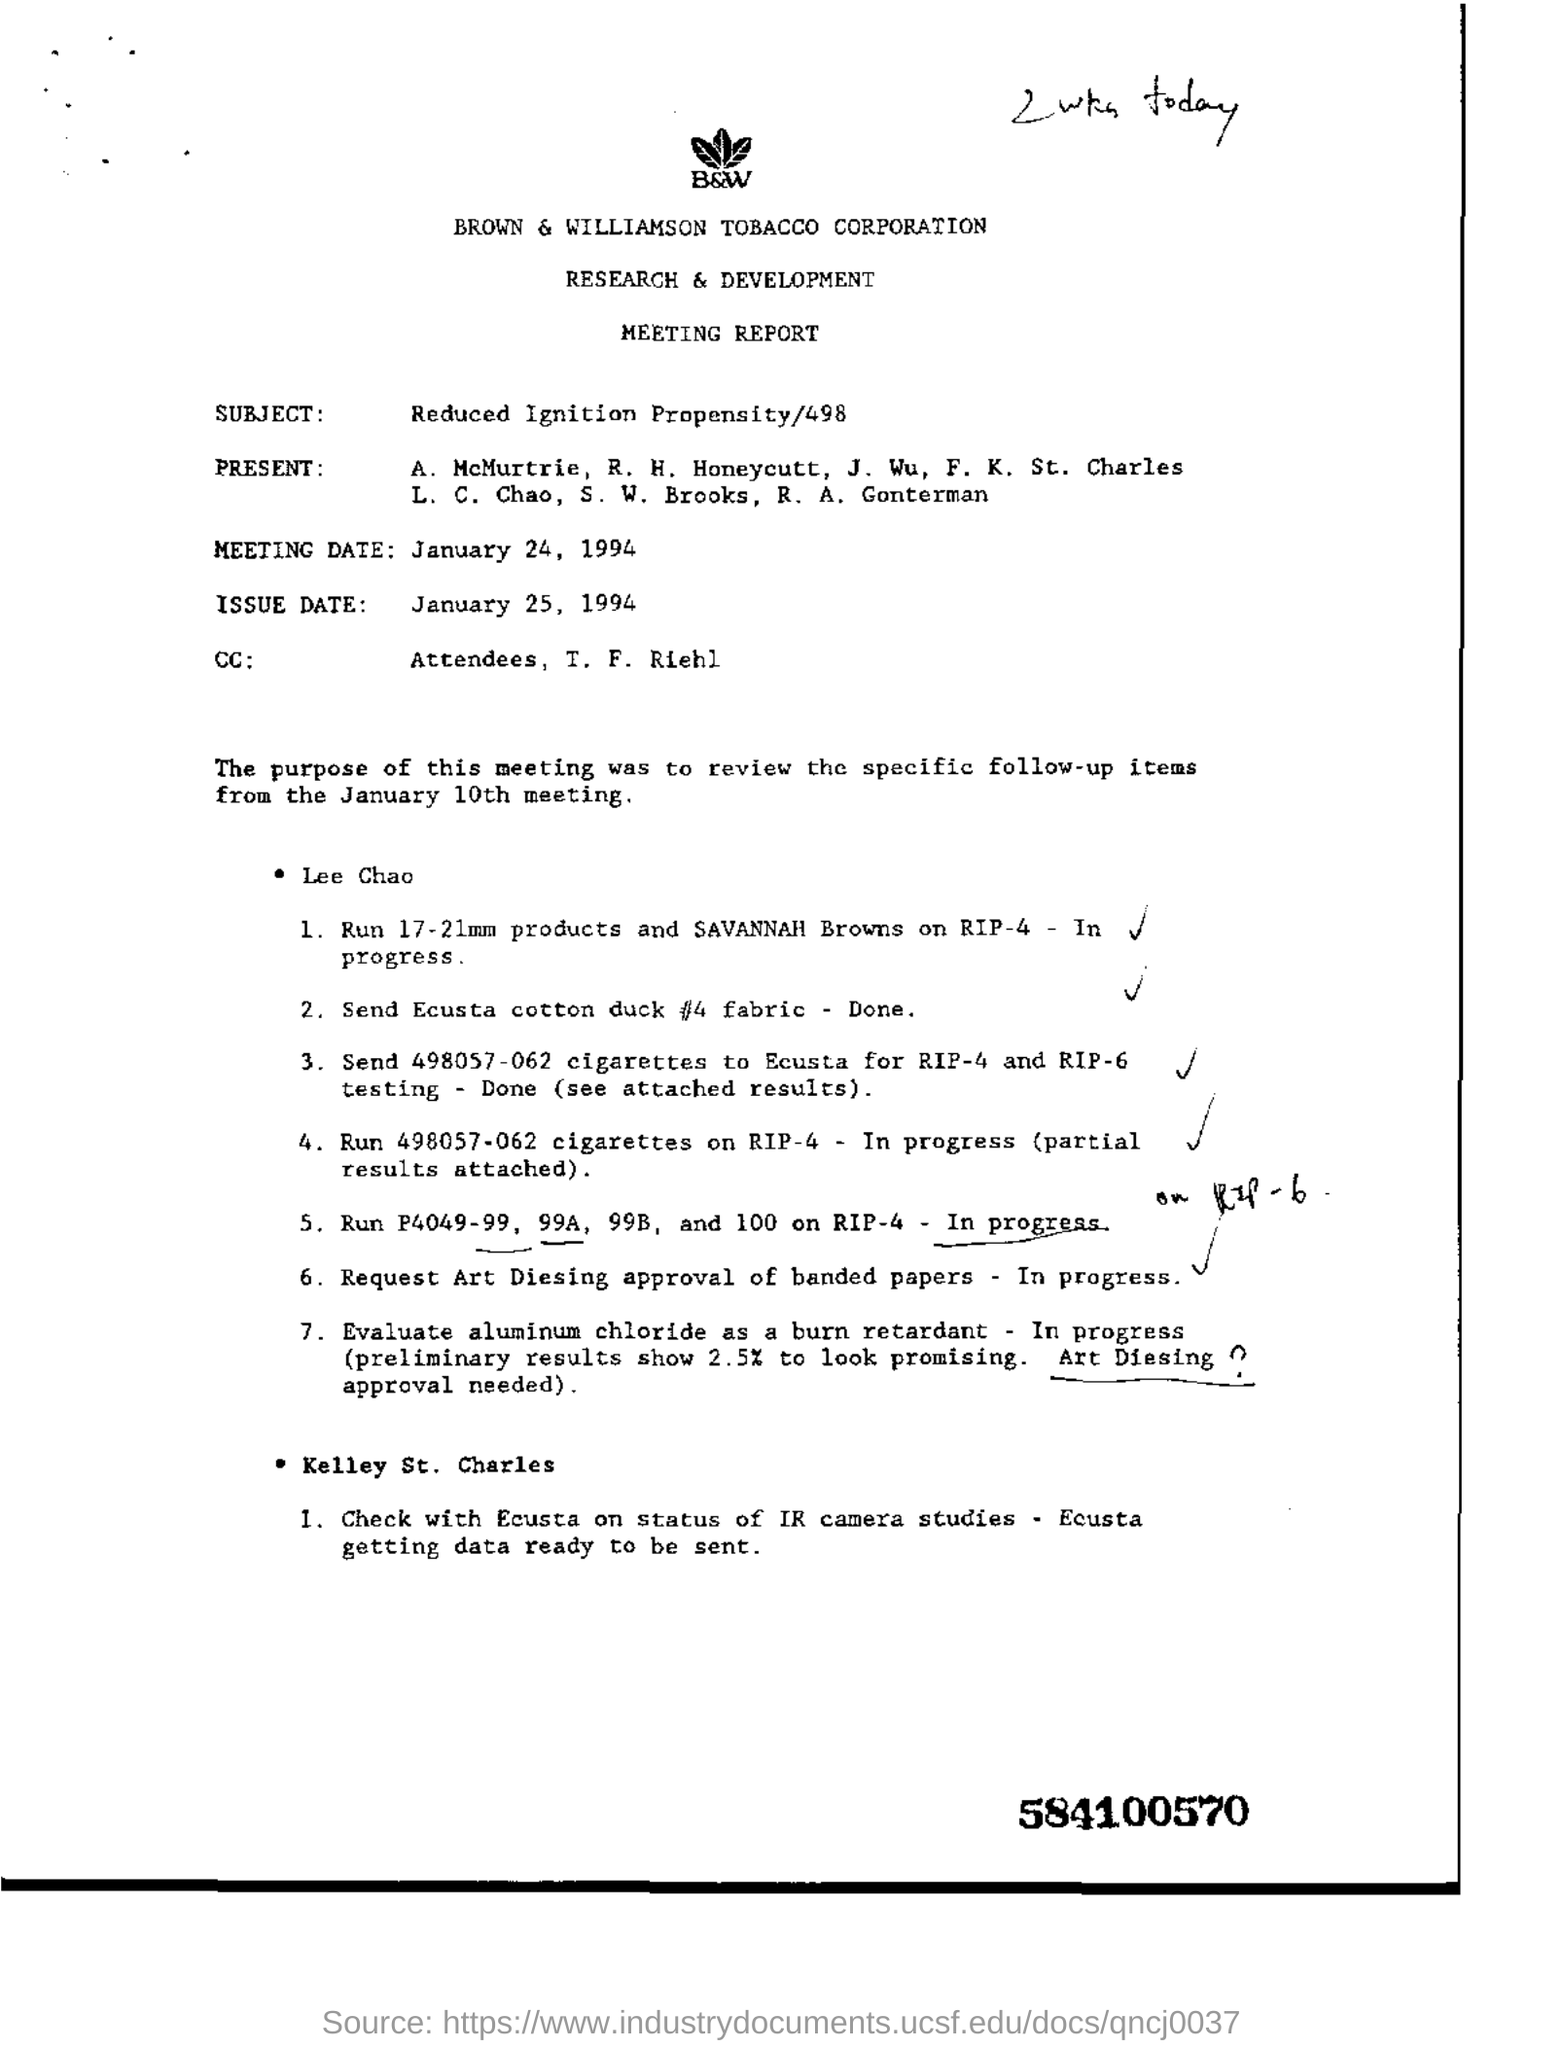What is the name of the corporation?
Keep it short and to the point. BROWN & WILLIAMSON TOBACCO corporation. What is the subject?
Offer a terse response. Reduced Ignition Propensity/498. What is the meeting date?
Your answer should be compact. January 24, 1994. 